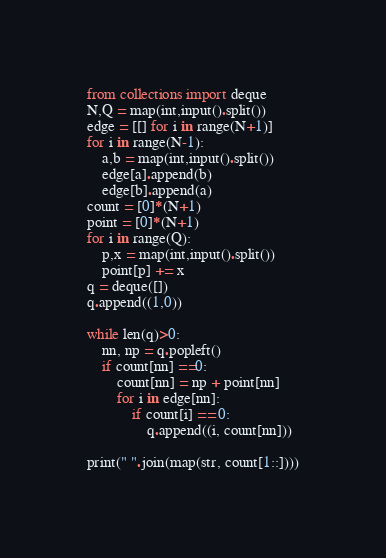<code> <loc_0><loc_0><loc_500><loc_500><_Python_>from collections import deque
N,Q = map(int,input().split())
edge = [[] for i in range(N+1)]
for i in range(N-1):
    a,b = map(int,input().split())
    edge[a].append(b)
    edge[b].append(a)
count = [0]*(N+1)
point = [0]*(N+1)
for i in range(Q):
    p,x = map(int,input().split())
    point[p] += x
q = deque([])
q.append((1,0))

while len(q)>0:
    nn, np = q.popleft()
    if count[nn] ==0:
        count[nn] = np + point[nn]
        for i in edge[nn]:
            if count[i] == 0:
                q.append((i, count[nn]))

print(" ".join(map(str, count[1::])))

</code> 